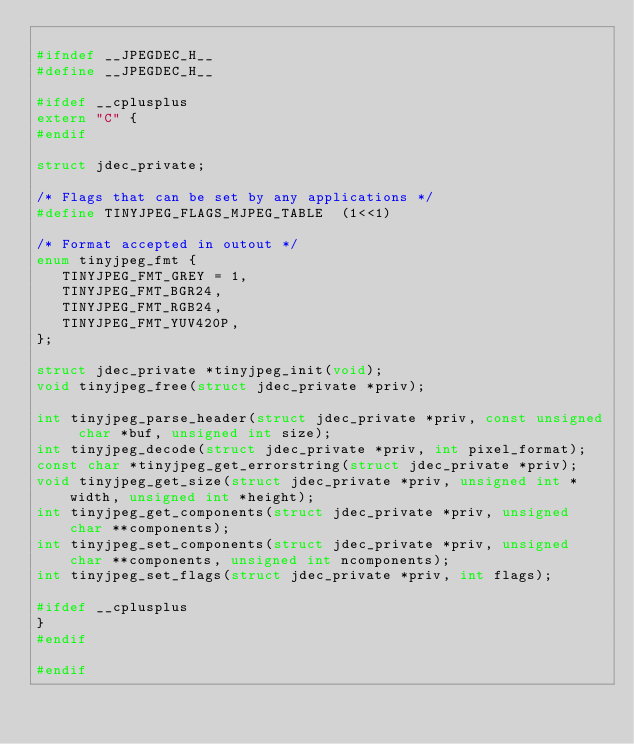Convert code to text. <code><loc_0><loc_0><loc_500><loc_500><_C_>
#ifndef __JPEGDEC_H__
#define __JPEGDEC_H__

#ifdef __cplusplus
extern "C" {
#endif

struct jdec_private;

/* Flags that can be set by any applications */
#define TINYJPEG_FLAGS_MJPEG_TABLE	(1<<1)

/* Format accepted in outout */
enum tinyjpeg_fmt {
   TINYJPEG_FMT_GREY = 1,
   TINYJPEG_FMT_BGR24,
   TINYJPEG_FMT_RGB24,
   TINYJPEG_FMT_YUV420P,
};

struct jdec_private *tinyjpeg_init(void);
void tinyjpeg_free(struct jdec_private *priv);

int tinyjpeg_parse_header(struct jdec_private *priv, const unsigned char *buf, unsigned int size);
int tinyjpeg_decode(struct jdec_private *priv, int pixel_format);
const char *tinyjpeg_get_errorstring(struct jdec_private *priv);
void tinyjpeg_get_size(struct jdec_private *priv, unsigned int *width, unsigned int *height);
int tinyjpeg_get_components(struct jdec_private *priv, unsigned char **components);
int tinyjpeg_set_components(struct jdec_private *priv, unsigned char **components, unsigned int ncomponents);
int tinyjpeg_set_flags(struct jdec_private *priv, int flags);

#ifdef __cplusplus
}
#endif

#endif



</code> 